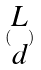Convert formula to latex. <formula><loc_0><loc_0><loc_500><loc_500>( \begin{matrix} L \\ d \end{matrix} )</formula> 